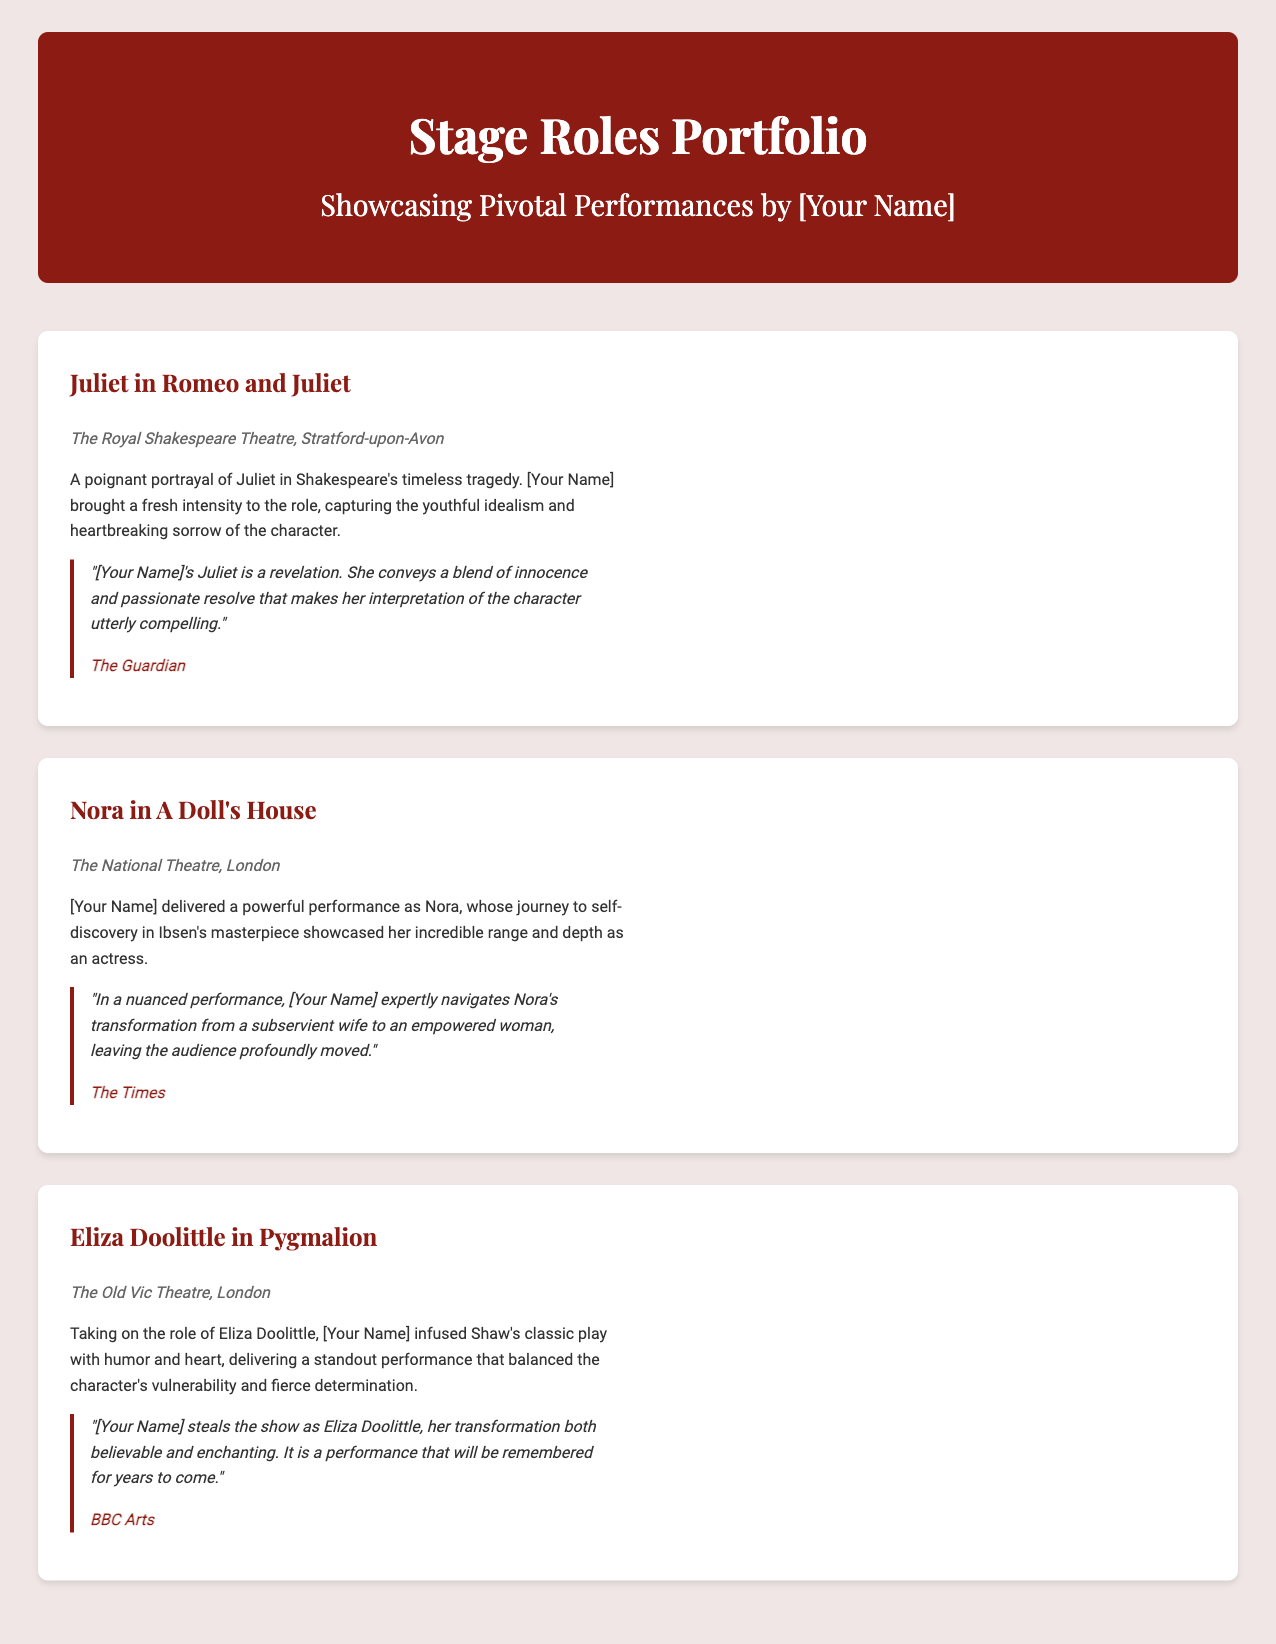What is the title of the portfolio? The title of the portfolio is prominently displayed in the header of the document.
Answer: Stage Roles Portfolio Who played Juliet in Romeo and Juliet? The document mentions the actress by name in the description of her role.
Answer: [Your Name] Where did the performance of Nora in A Doll's House take place? The location of the performance is provided in the theater information section of the document.
Answer: The National Theatre, London Which character is portrayed by [Your Name] in Pygmalion? The character played is specified in the title of the corresponding section.
Answer: Eliza Doolittle Which publication praised [Your Name]'s portrayal of Juliet? The critic's name is included in the quote at the end of the Juliet section.
Answer: The Guardian What performance showcased a transition from a subservient wife to an empowered woman? The description for the role of Nora in A Doll's House details this transformation.
Answer: A Doll's House How many major stage roles are highlighted in the portfolio? The document contains multiple sections, each representing a major stage role, allowing for a numerical count.
Answer: Three What is emphasized about [Your Name]'s performance in Pygmalion? The document highlights a specific quality of the performance in the description of the role.
Answer: Humor and heart Which theater hosted the performance of Juliet? The theater's name is noted in the description section of the role of Juliet.
Answer: The Royal Shakespeare Theatre, Stratford-upon-Avon 